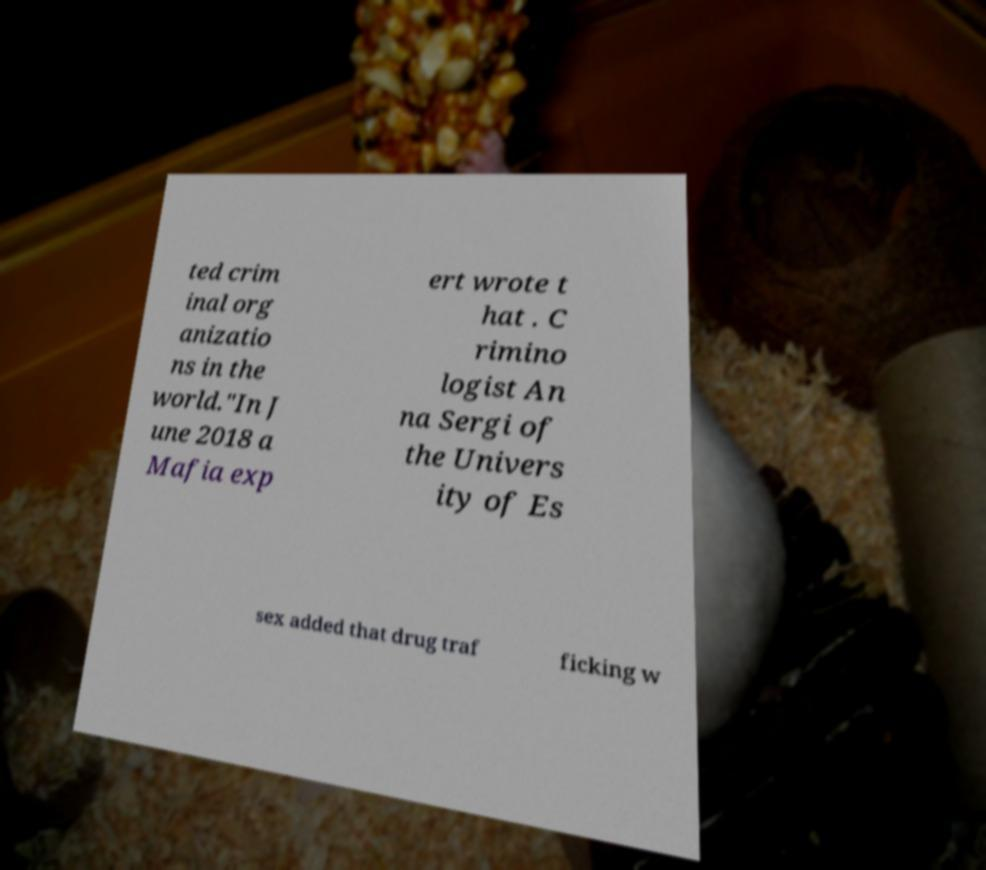For documentation purposes, I need the text within this image transcribed. Could you provide that? ted crim inal org anizatio ns in the world."In J une 2018 a Mafia exp ert wrote t hat . C rimino logist An na Sergi of the Univers ity of Es sex added that drug traf ficking w 